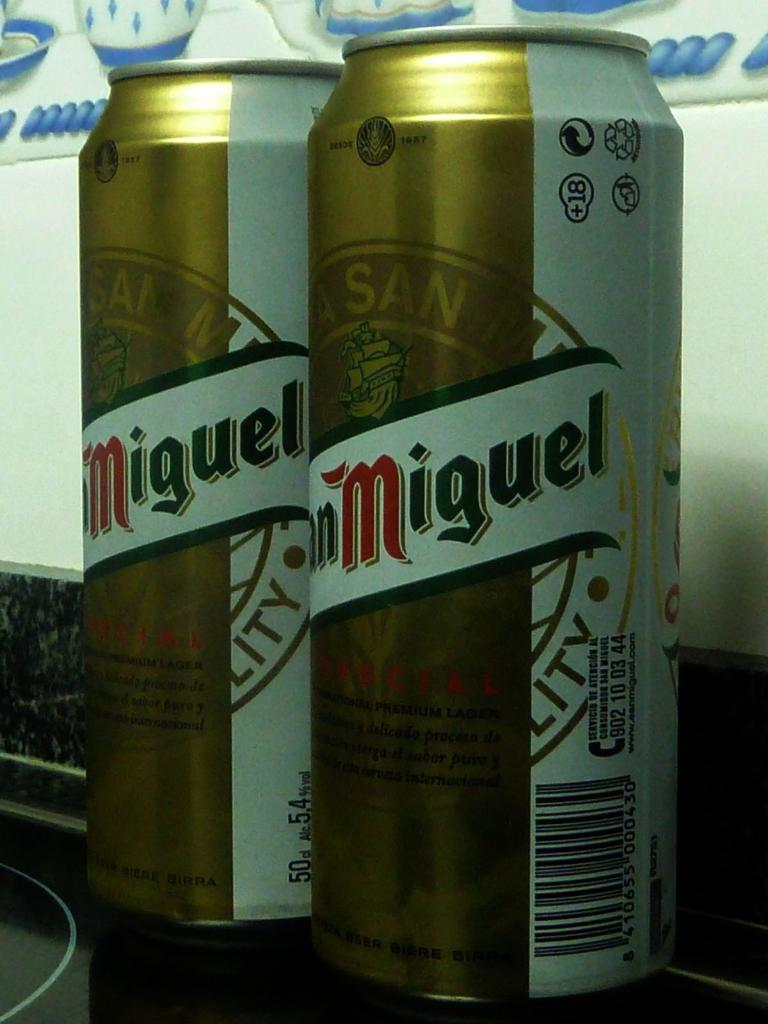Provide a one-sentence caption for the provided image. Two cans of  San Miguel' beer are shown in the image. 